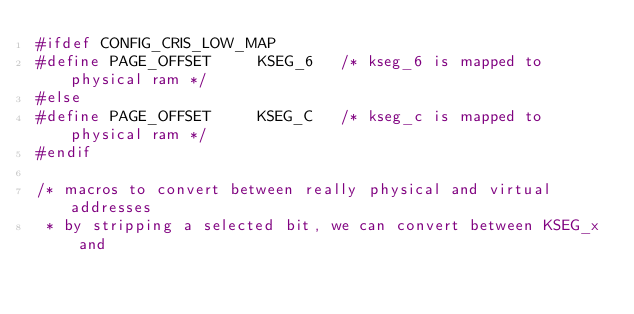Convert code to text. <code><loc_0><loc_0><loc_500><loc_500><_C_>#ifdef CONFIG_CRIS_LOW_MAP
#define PAGE_OFFSET		KSEG_6   /* kseg_6 is mapped to physical ram */
#else
#define PAGE_OFFSET		KSEG_C   /* kseg_c is mapped to physical ram */
#endif

/* macros to convert between really physical and virtual addresses
 * by stripping a selected bit, we can convert between KSEG_x and</code> 